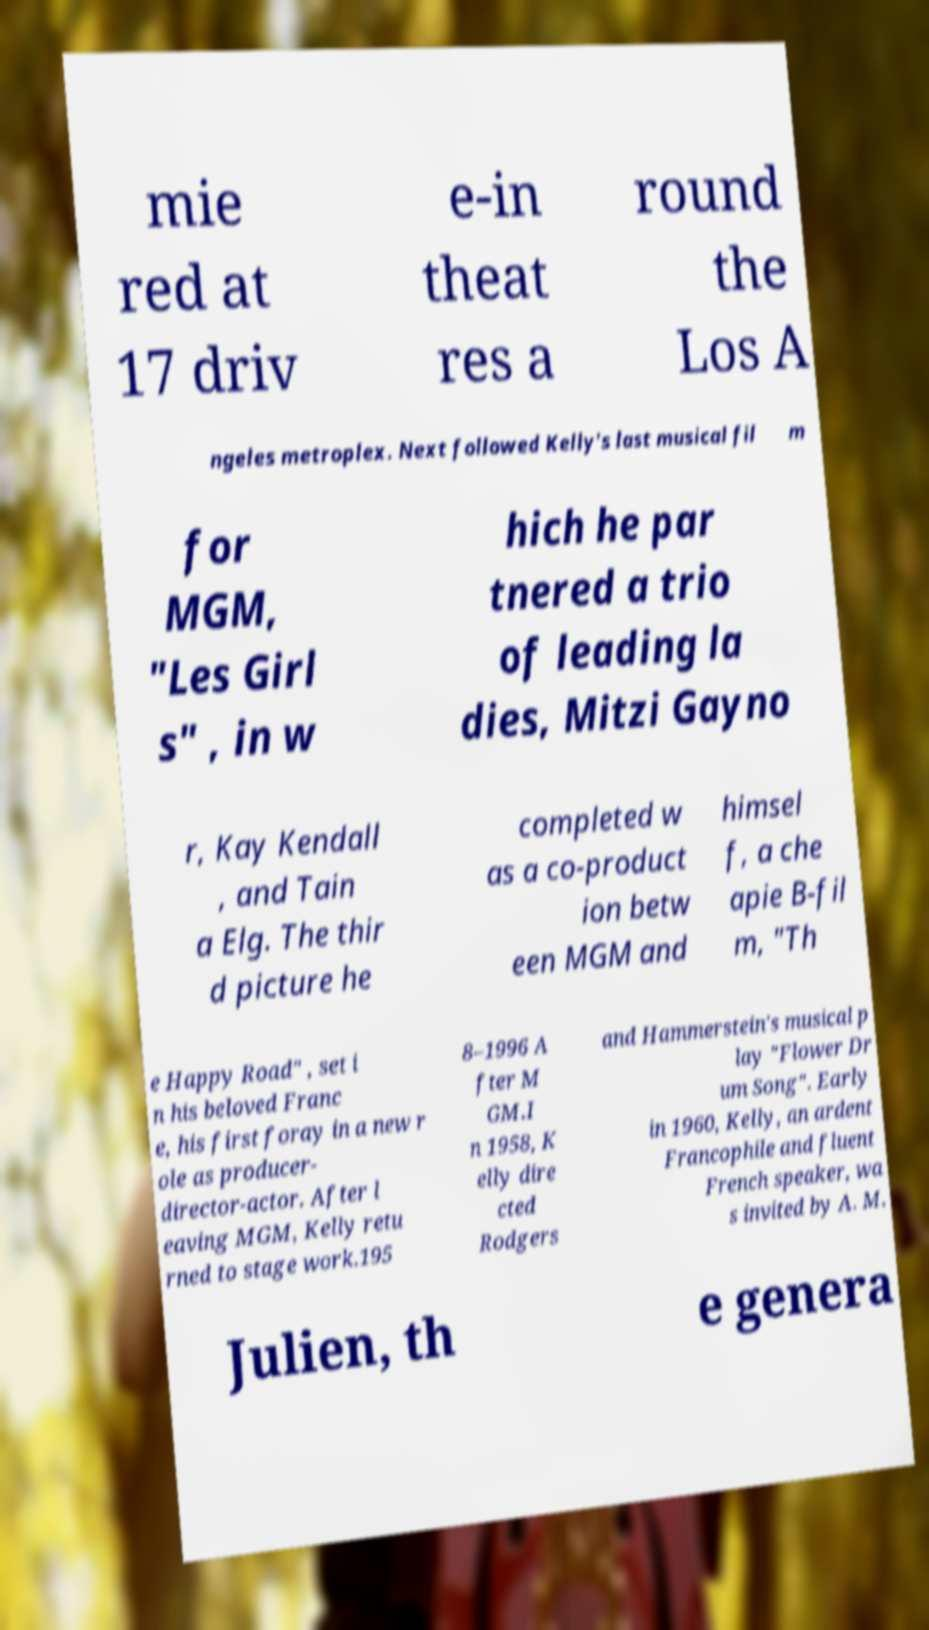Please identify and transcribe the text found in this image. mie red at 17 driv e-in theat res a round the Los A ngeles metroplex. Next followed Kelly's last musical fil m for MGM, "Les Girl s" , in w hich he par tnered a trio of leading la dies, Mitzi Gayno r, Kay Kendall , and Tain a Elg. The thir d picture he completed w as a co-product ion betw een MGM and himsel f, a che apie B-fil m, "Th e Happy Road" , set i n his beloved Franc e, his first foray in a new r ole as producer- director-actor. After l eaving MGM, Kelly retu rned to stage work.195 8–1996 A fter M GM.I n 1958, K elly dire cted Rodgers and Hammerstein's musical p lay "Flower Dr um Song". Early in 1960, Kelly, an ardent Francophile and fluent French speaker, wa s invited by A. M. Julien, th e genera 